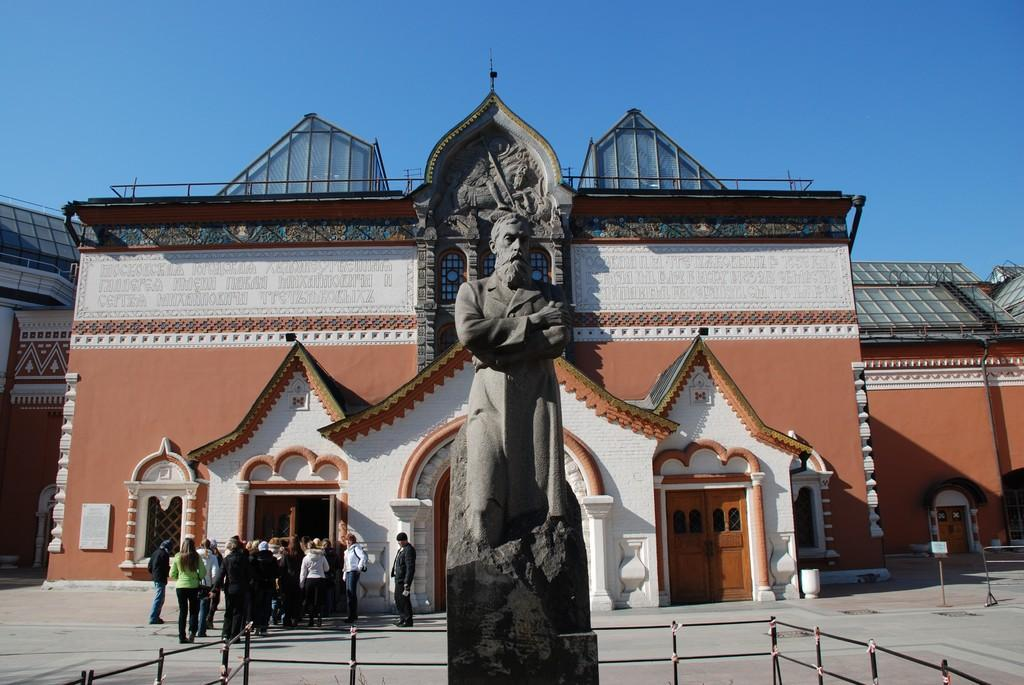What is the main subject in the image? There is a statue in the image. Where is the statue located in relation to the other elements in the image? The statue is at the forefront of the image. What else can be seen in the background of the image? There are people standing in the background of the image. What type of cork can be seen in the girl's hair in the image? There is no girl or cork present in the image; it features a statue and people in the background. 